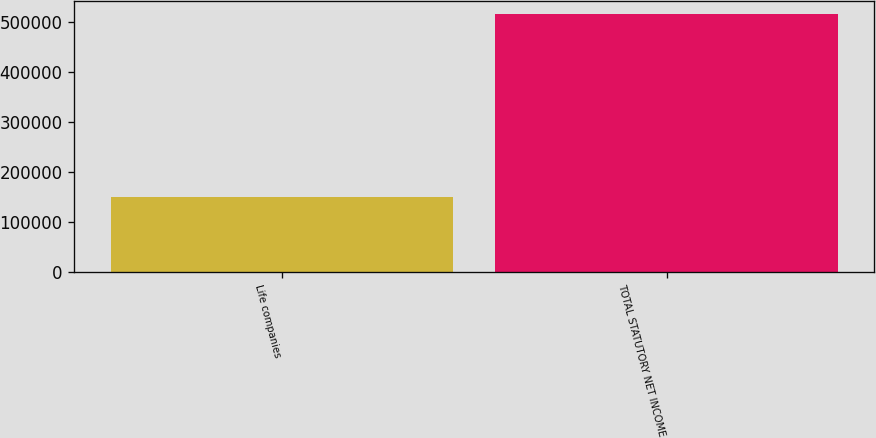<chart> <loc_0><loc_0><loc_500><loc_500><bar_chart><fcel>Life companies<fcel>TOTAL STATUTORY NET INCOME<nl><fcel>148554<fcel>515869<nl></chart> 